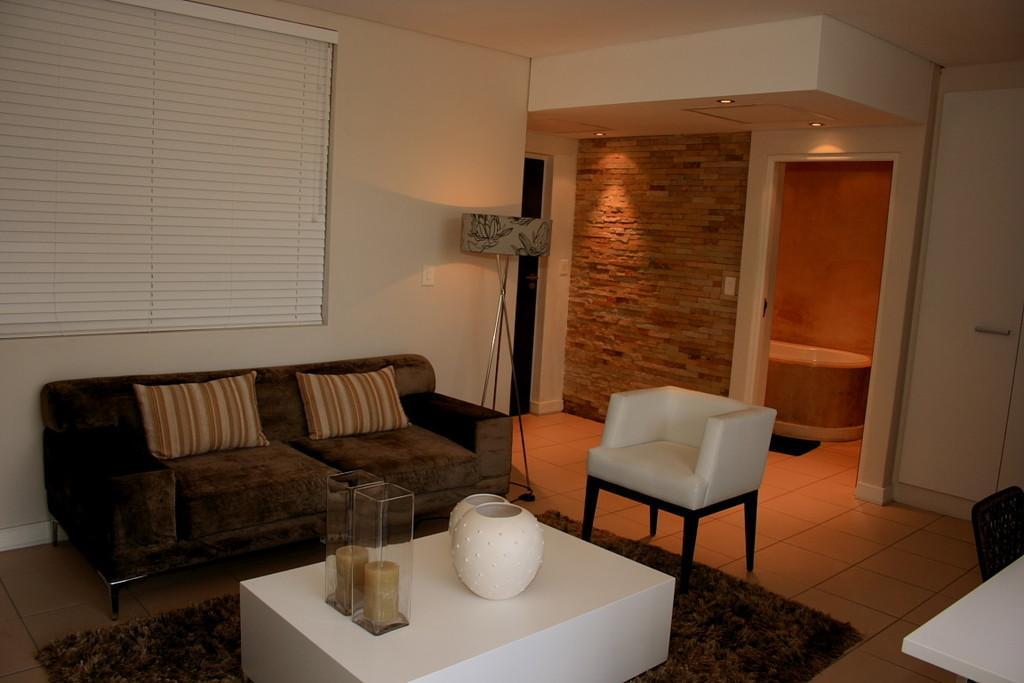Please provide a concise description of this image. there is a living room in which sofa table and lights are present 